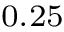<formula> <loc_0><loc_0><loc_500><loc_500>_ { 0 . 2 5 }</formula> 